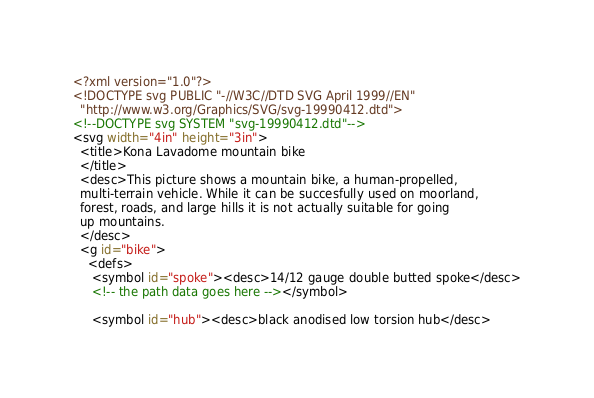Convert code to text. <code><loc_0><loc_0><loc_500><loc_500><_XML_><?xml version="1.0"?>
<!DOCTYPE svg PUBLIC "-//W3C//DTD SVG April 1999//EN" 
  "http://www.w3.org/Graphics/SVG/svg-19990412.dtd">
<!--DOCTYPE svg SYSTEM "svg-19990412.dtd"-->
<svg width="4in" height="3in">
  <title>Kona Lavadome mountain bike
  </title>
  <desc>This picture shows a mountain bike, a human-propelled, 
  multi-terrain vehicle. While it can be succesfully used on moorland, 
  forest, roads, and large hills it is not actually suitable for going 
  up mountains.
  </desc>
  <g id="bike">
    <defs>
     <symbol id="spoke"><desc>14/12 gauge double butted spoke</desc>
     <!-- the path data goes here --></symbol>
     
     <symbol id="hub"><desc>black anodised low torsion hub</desc></code> 